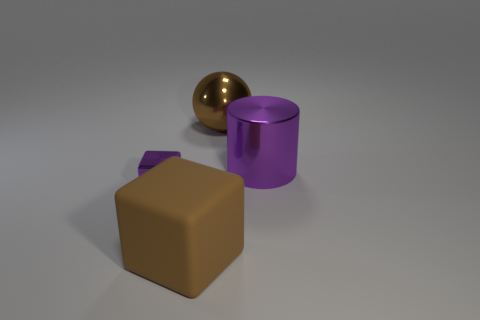Add 2 green cylinders. How many objects exist? 6 Subtract all cylinders. How many objects are left? 3 Add 2 metallic cubes. How many metallic cubes exist? 3 Subtract 0 blue balls. How many objects are left? 4 Subtract all tiny purple metallic cubes. Subtract all small purple objects. How many objects are left? 2 Add 1 small metallic cubes. How many small metallic cubes are left? 2 